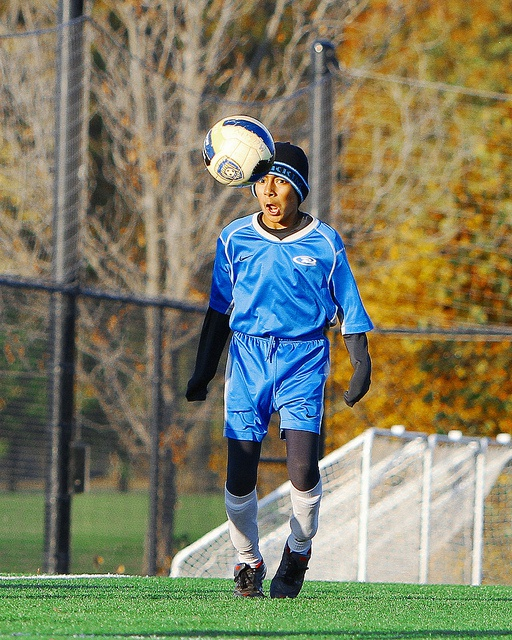Describe the objects in this image and their specific colors. I can see people in olive, black, lightblue, and blue tones and sports ball in olive, beige, black, and darkgray tones in this image. 